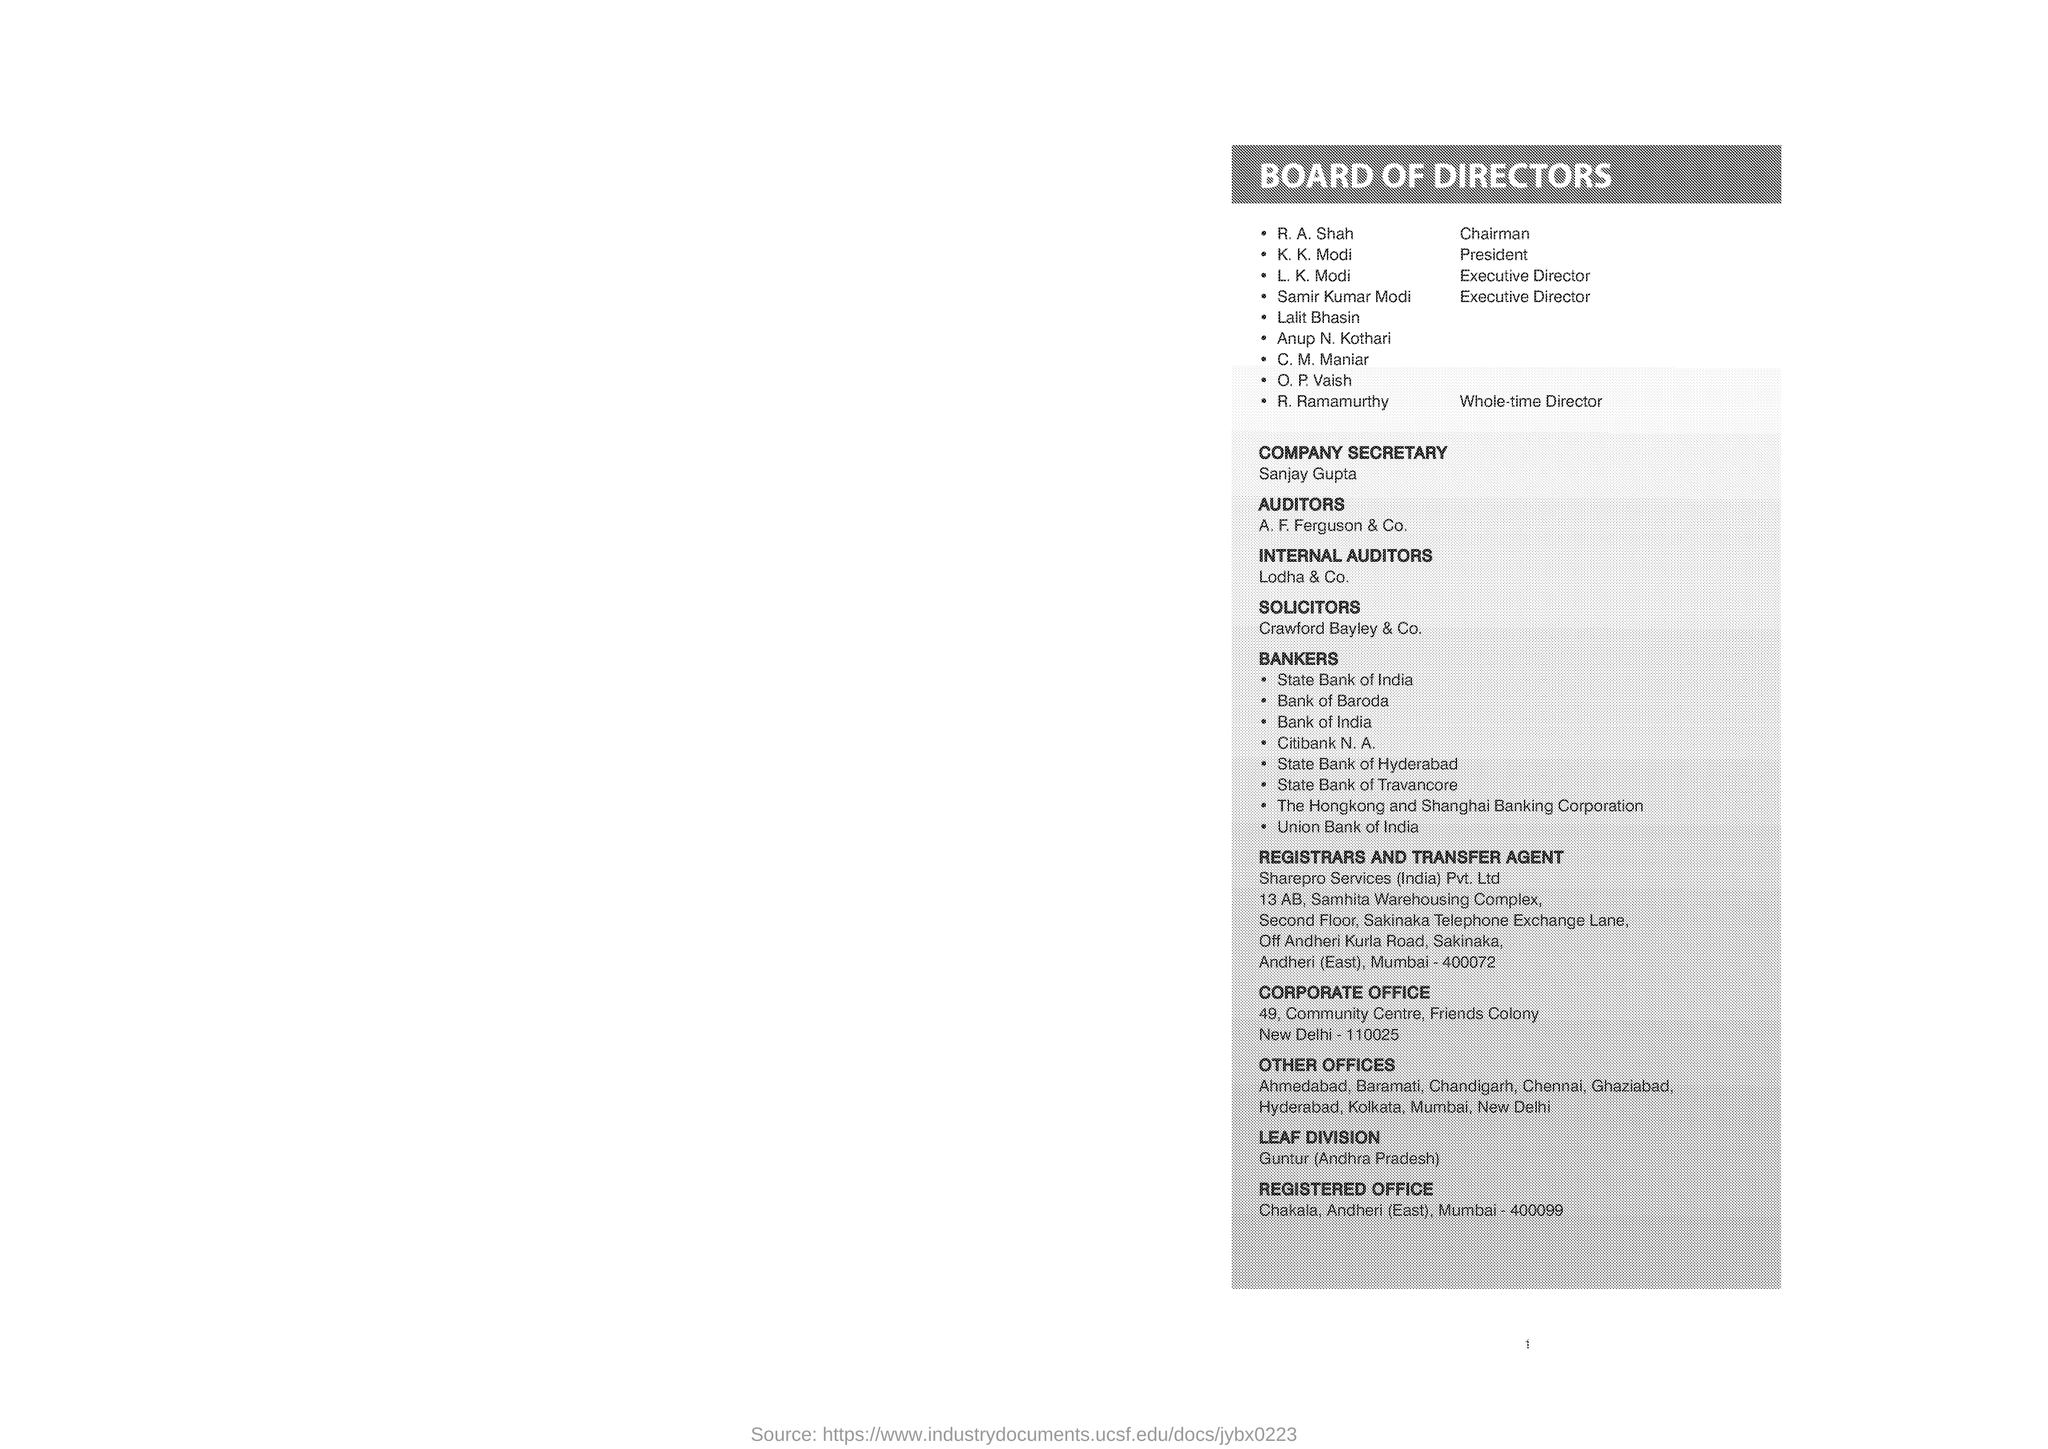What is the first name in the list of board of directors?
Offer a very short reply. R. A. Shah. Who is the whole time director?
Keep it short and to the point. R. ramamurthy. Who is the company secretary?
Offer a very short reply. Sanjay gupta. Where is the leaf division?
Make the answer very short. Guntur (Andhra Pradesh). In which city is the corporate office?
Provide a short and direct response. New Delhi. In which city is the registered office?
Give a very brief answer. Mumbai. Who is the president?
Make the answer very short. K. K. Modi. Who is the registrars and transfer agent?
Your answer should be very brief. Sharepro services (india) pvt. ltd. 